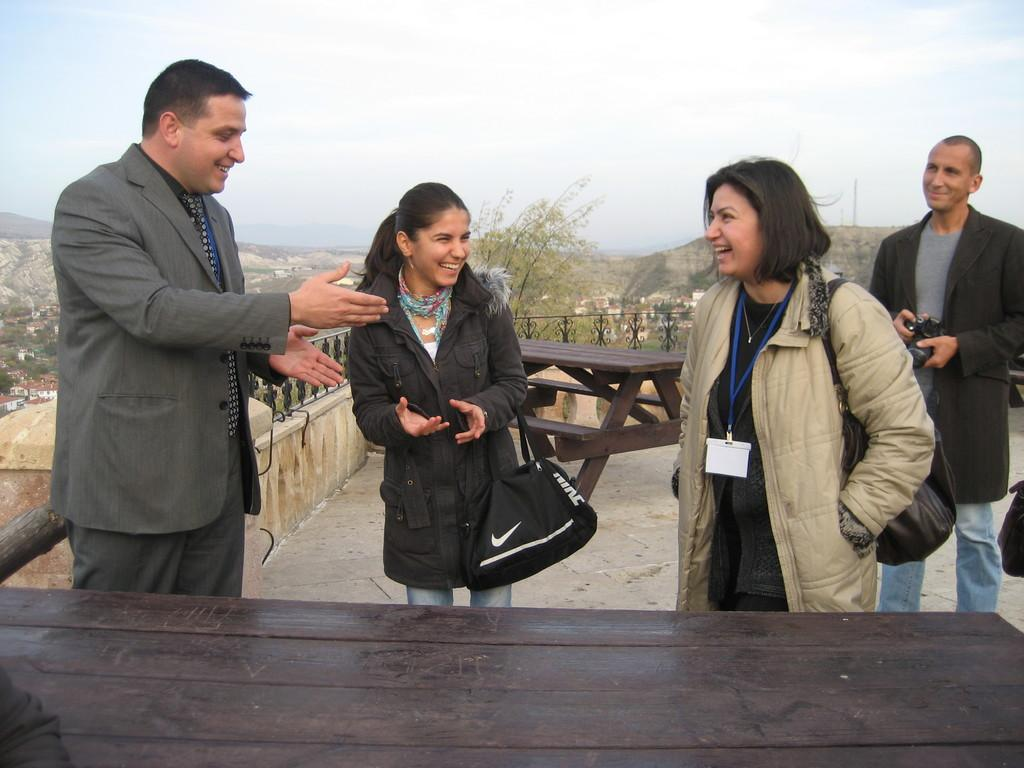How many people are in the image? There are four persons standing in the image. What are the people doing in the image? The persons are standing. What type of furniture can be seen in the image? There are tables in the image. What architectural feature is present in the image? There are iron grilles in the image. What type of structures can be seen in the image? There are buildings in the image. What type of vegetation is present in the image? There are trees in the image. What type of natural feature is present in the image? There are hills in the image. What is visible in the background of the image? The sky is visible in the background of the image. What type of wound can be seen on the person's arm in the image? There is no wound visible on any person's arm in the image. In which direction are the people facing in the image? The provided facts do not specify the direction the people are facing, only that they are standing. 